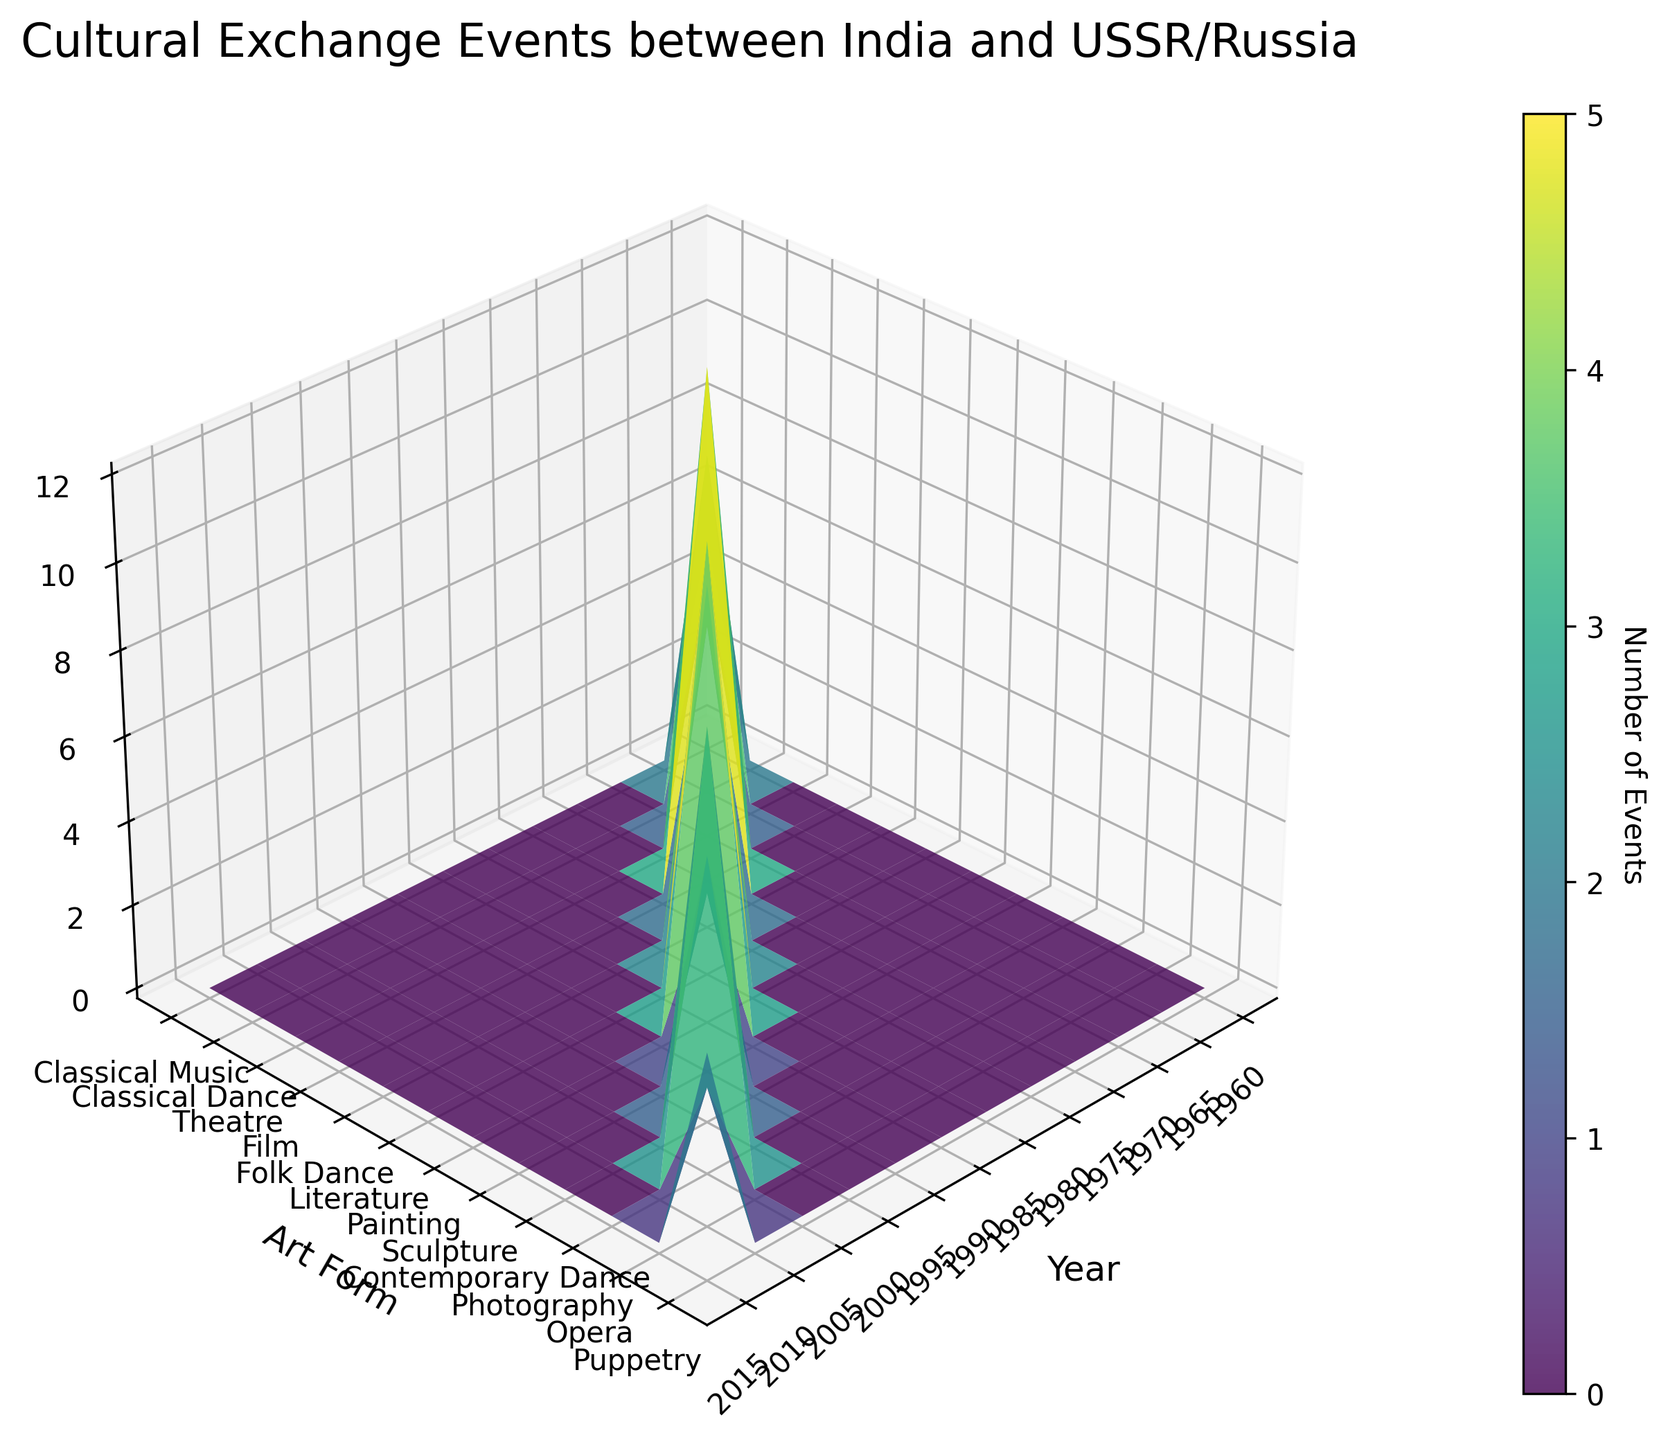what is the title of the plot? The title of the plot is often displayed prominently at the top. By looking at the 3D surface plot's title area, you can see the title.
Answer: Cultural Exchange Events between India and USSR/Russia Which art form had the highest number of events in 1975? Look for the column corresponding to the year 1975 and identify the highest value in that column. Check the row label for this value to find the corresponding art form.
Answer: Film How many classical dance events were held in 1965? Find the row labeled "Classical Dance" and then look at the column for the year 1965 to identify the number of events.
Answer: 8 What is the total number of events held in Moscow across all years? Sum the values along the row labeled "Moscow" in the plot.
Answer: 5 What is the average number of events for the art form 'Photography' across all years? Find the row for 'Photography' and sum the values, then divide by the number of years with events.
Answer: 10 Which year had the highest overall number of events? Sum the values for each column representing each year, and identify which column has the highest sum.
Answer: 1975 Which location hosted the least number of classical music events across all years? Compare the values in the 'Classical Music' rows for each location and find the lowest value.
Answer: Moscow What is the difference in the number of events between Theatre in 1970 and Puppetry in 2015? Locate the number of events for Theatre in 1970 and Puppetry in 2015, and subtract one from the other to find the difference.
Answer: 1 (6 - 5) What is the trend of events held for the art form 'Literature' over the years? Check the row labeled 'Literature' and observe how the number of events changes over the years presented in the plot.
Answer: Peaks in 1985 with 9 events Which art form had more events in 1990, Painting or Classical Dance? Compare the number of events in the plot for Painting and Classical Dance in 1990, and see which one is higher.
Answer: Painting 